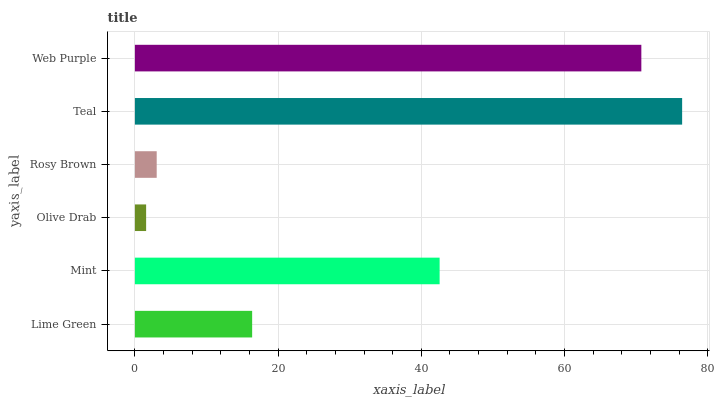Is Olive Drab the minimum?
Answer yes or no. Yes. Is Teal the maximum?
Answer yes or no. Yes. Is Mint the minimum?
Answer yes or no. No. Is Mint the maximum?
Answer yes or no. No. Is Mint greater than Lime Green?
Answer yes or no. Yes. Is Lime Green less than Mint?
Answer yes or no. Yes. Is Lime Green greater than Mint?
Answer yes or no. No. Is Mint less than Lime Green?
Answer yes or no. No. Is Mint the high median?
Answer yes or no. Yes. Is Lime Green the low median?
Answer yes or no. Yes. Is Olive Drab the high median?
Answer yes or no. No. Is Web Purple the low median?
Answer yes or no. No. 